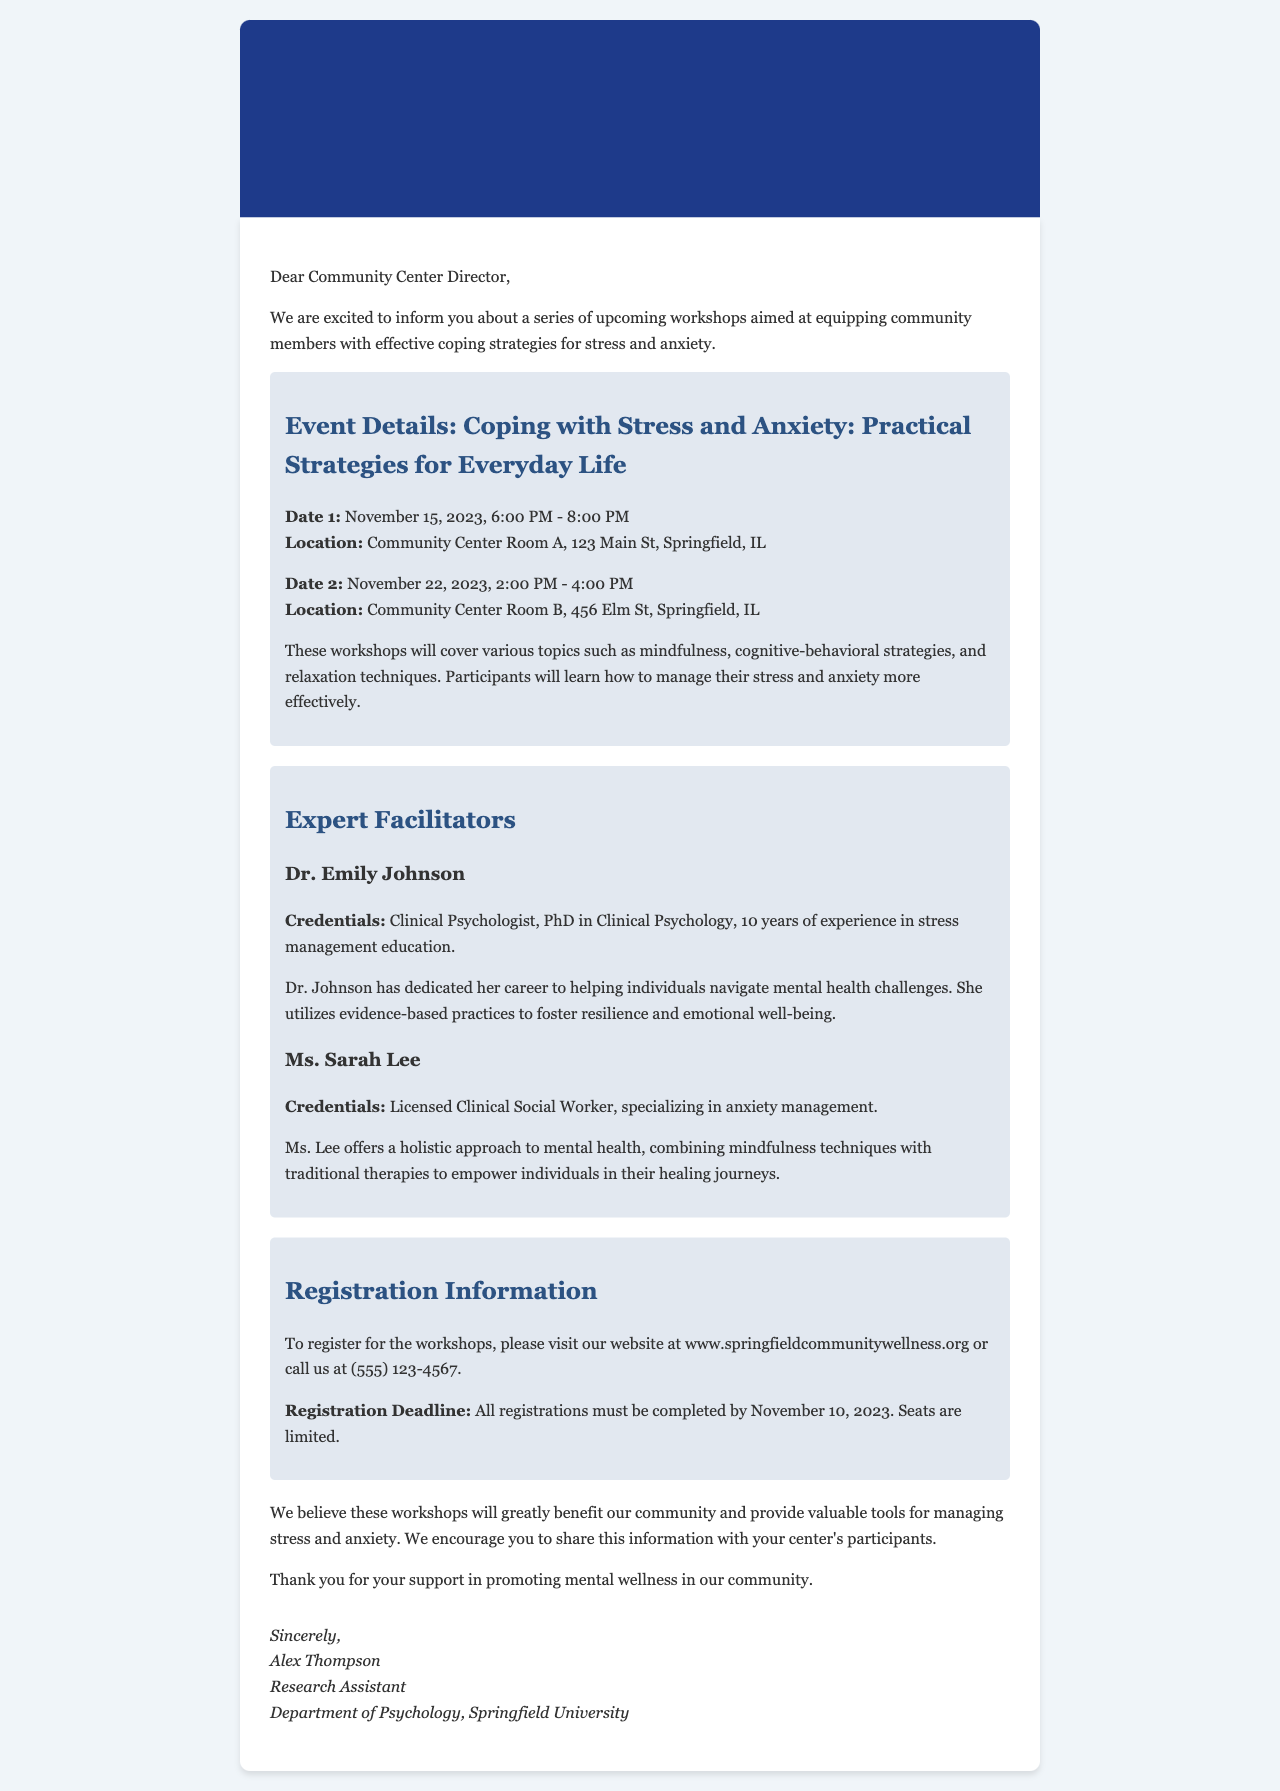What is the first workshop date? The first workshop date is mentioned in the event details section of the document.
Answer: November 15, 2023 What is the location for the second workshop? The location for the second workshop is provided in the event details section of the document.
Answer: Community Center Room B, 456 Elm St, Springfield, IL Who is the facilitator with a PhD in Clinical Psychology? The document lists the expert facilitators, and one is mentioned with these credentials.
Answer: Dr. Emily Johnson What is the registration deadline? The registration deadline is specified in the registration information section of the document.
Answer: November 10, 2023 How long will the first workshop last? The duration of the first workshop can be inferred from the timings given in the event details.
Answer: 2 hours What are the two main topics covered in the workshops? The document lists various topics covered in the workshops in the event details section.
Answer: Mindfulness and cognitive-behavioral strategies What is the website for registration? The registration information in the document provides this website.
Answer: www.springfieldcommunitywellness.org Who is the author of the letter? The signature section of the document contains the name of the author.
Answer: Alex Thompson 